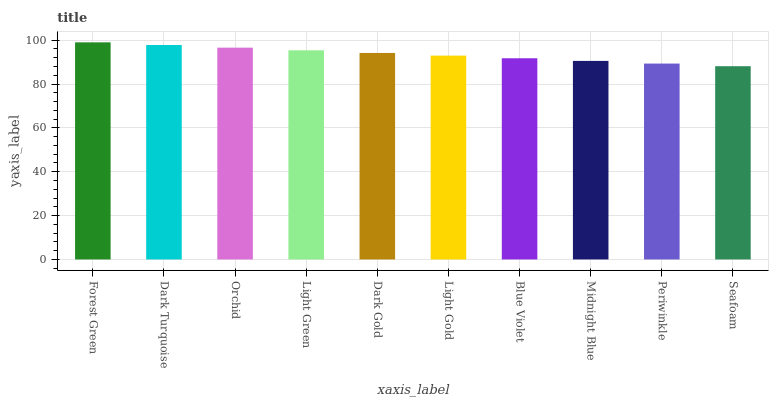Is Seafoam the minimum?
Answer yes or no. Yes. Is Forest Green the maximum?
Answer yes or no. Yes. Is Dark Turquoise the minimum?
Answer yes or no. No. Is Dark Turquoise the maximum?
Answer yes or no. No. Is Forest Green greater than Dark Turquoise?
Answer yes or no. Yes. Is Dark Turquoise less than Forest Green?
Answer yes or no. Yes. Is Dark Turquoise greater than Forest Green?
Answer yes or no. No. Is Forest Green less than Dark Turquoise?
Answer yes or no. No. Is Dark Gold the high median?
Answer yes or no. Yes. Is Light Gold the low median?
Answer yes or no. Yes. Is Periwinkle the high median?
Answer yes or no. No. Is Forest Green the low median?
Answer yes or no. No. 